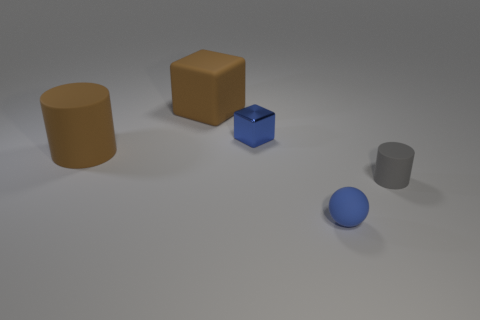Do the blue matte sphere and the blue block have the same size?
Provide a succinct answer. Yes. What shape is the matte thing that is in front of the tiny blue shiny object and behind the tiny gray cylinder?
Give a very brief answer. Cylinder. What number of cylinders have the same material as the tiny block?
Keep it short and to the point. 0. How many tiny blue shiny objects are on the right side of the big rubber thing in front of the tiny cube?
Give a very brief answer. 1. What is the shape of the big brown matte thing in front of the brown object that is behind the small thing that is left of the small blue rubber object?
Your response must be concise. Cylinder. What is the size of the shiny block that is the same color as the tiny ball?
Keep it short and to the point. Small. How many things are tiny shiny cylinders or small rubber cylinders?
Your answer should be compact. 1. The block that is the same size as the brown matte cylinder is what color?
Give a very brief answer. Brown. There is a metallic thing; does it have the same shape as the big rubber object behind the tiny blue shiny block?
Your answer should be very brief. Yes. What number of things are blue objects in front of the blue cube or gray matte things on the right side of the brown matte cylinder?
Keep it short and to the point. 2. 